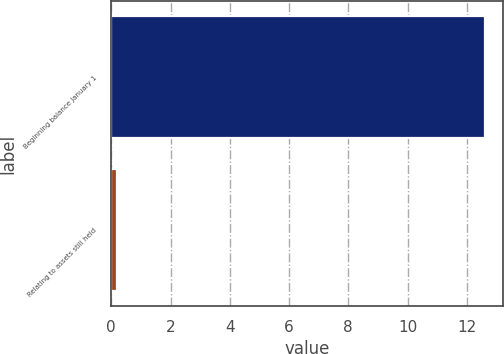Convert chart. <chart><loc_0><loc_0><loc_500><loc_500><bar_chart><fcel>Beginning balance January 1<fcel>Relating to assets still held<nl><fcel>12.6<fcel>0.2<nl></chart> 